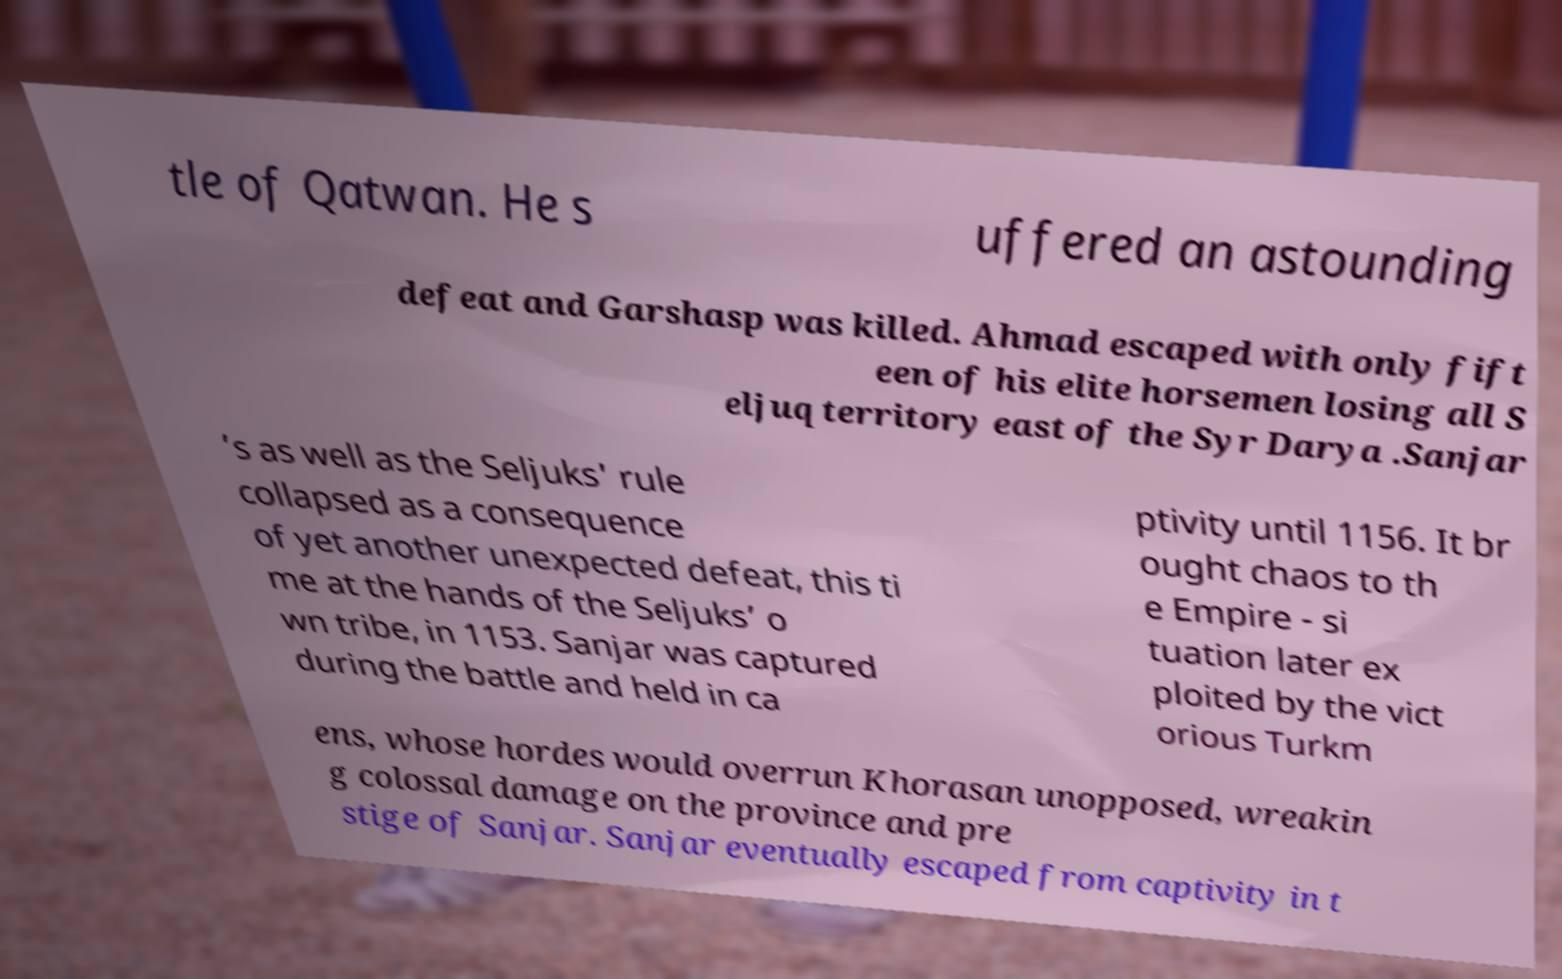Could you extract and type out the text from this image? tle of Qatwan. He s uffered an astounding defeat and Garshasp was killed. Ahmad escaped with only fift een of his elite horsemen losing all S eljuq territory east of the Syr Darya .Sanjar ’s as well as the Seljuks' rule collapsed as a consequence of yet another unexpected defeat, this ti me at the hands of the Seljuks’ o wn tribe, in 1153. Sanjar was captured during the battle and held in ca ptivity until 1156. It br ought chaos to th e Empire - si tuation later ex ploited by the vict orious Turkm ens, whose hordes would overrun Khorasan unopposed, wreakin g colossal damage on the province and pre stige of Sanjar. Sanjar eventually escaped from captivity in t 